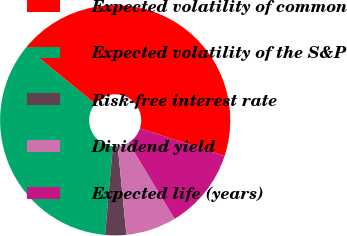<chart> <loc_0><loc_0><loc_500><loc_500><pie_chart><fcel>Expected volatility of common<fcel>Expected volatility of the S&P<fcel>Risk-free interest rate<fcel>Dividend yield<fcel>Expected life (years)<nl><fcel>44.11%<fcel>34.52%<fcel>2.96%<fcel>7.08%<fcel>11.33%<nl></chart> 